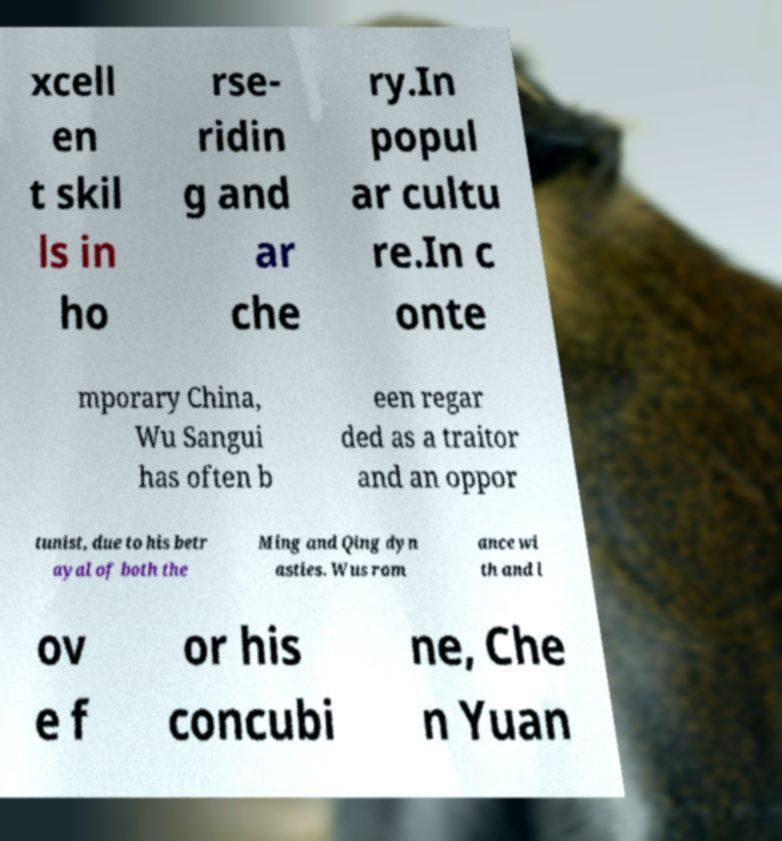Could you assist in decoding the text presented in this image and type it out clearly? xcell en t skil ls in ho rse- ridin g and ar che ry.In popul ar cultu re.In c onte mporary China, Wu Sangui has often b een regar ded as a traitor and an oppor tunist, due to his betr ayal of both the Ming and Qing dyn asties. Wus rom ance wi th and l ov e f or his concubi ne, Che n Yuan 